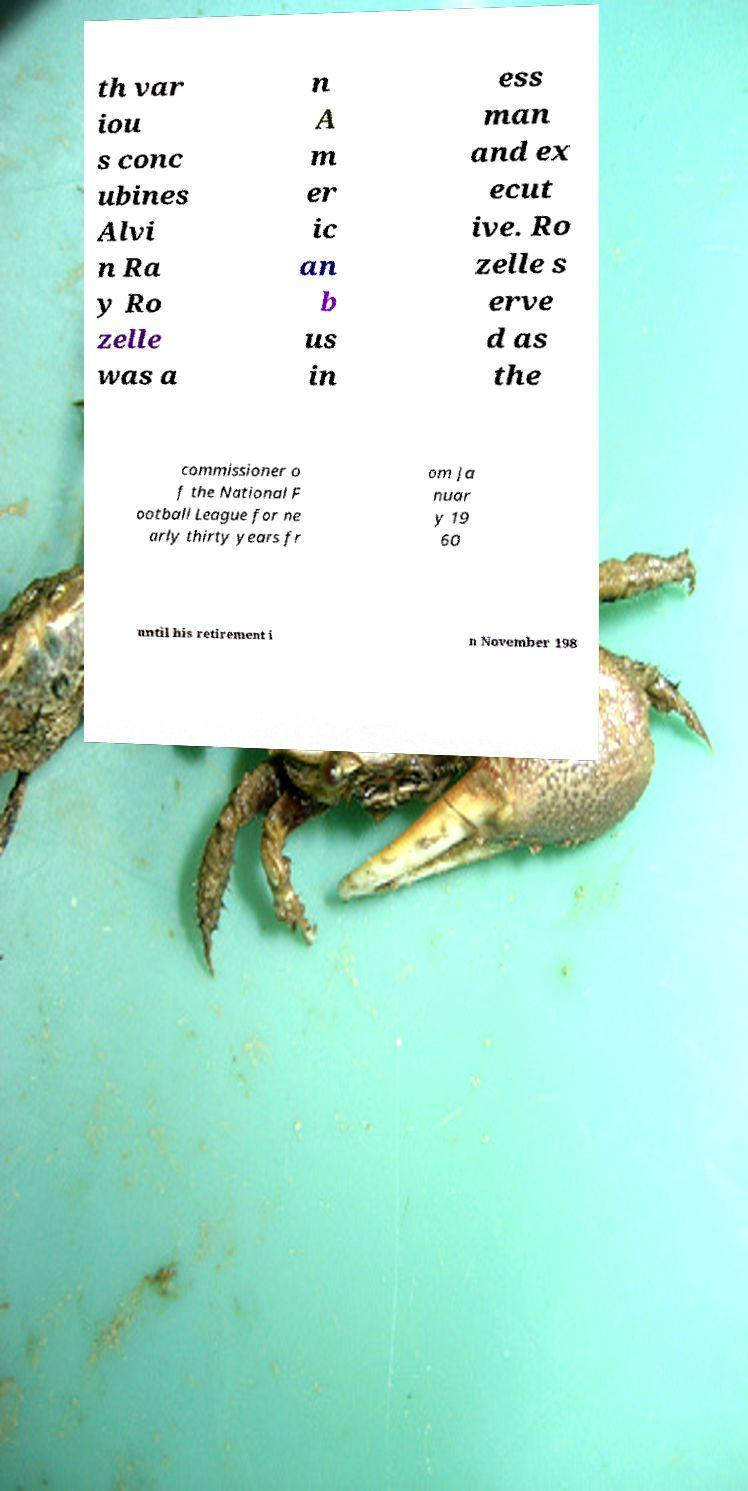Could you extract and type out the text from this image? th var iou s conc ubines Alvi n Ra y Ro zelle was a n A m er ic an b us in ess man and ex ecut ive. Ro zelle s erve d as the commissioner o f the National F ootball League for ne arly thirty years fr om Ja nuar y 19 60 until his retirement i n November 198 